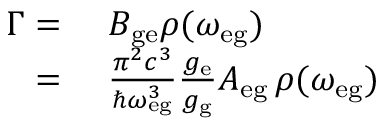Convert formula to latex. <formula><loc_0><loc_0><loc_500><loc_500>\begin{array} { r l } { \Gamma = } & \, B _ { g e } \rho ( \omega _ { e g } ) } \\ { = } & \, \frac { \pi ^ { 2 } c ^ { 3 } } { \hbar { \omega } _ { e g } ^ { 3 } } \frac { g _ { e } } { g _ { g } } A _ { e g } \, \rho ( \omega _ { e g } ) } \end{array}</formula> 